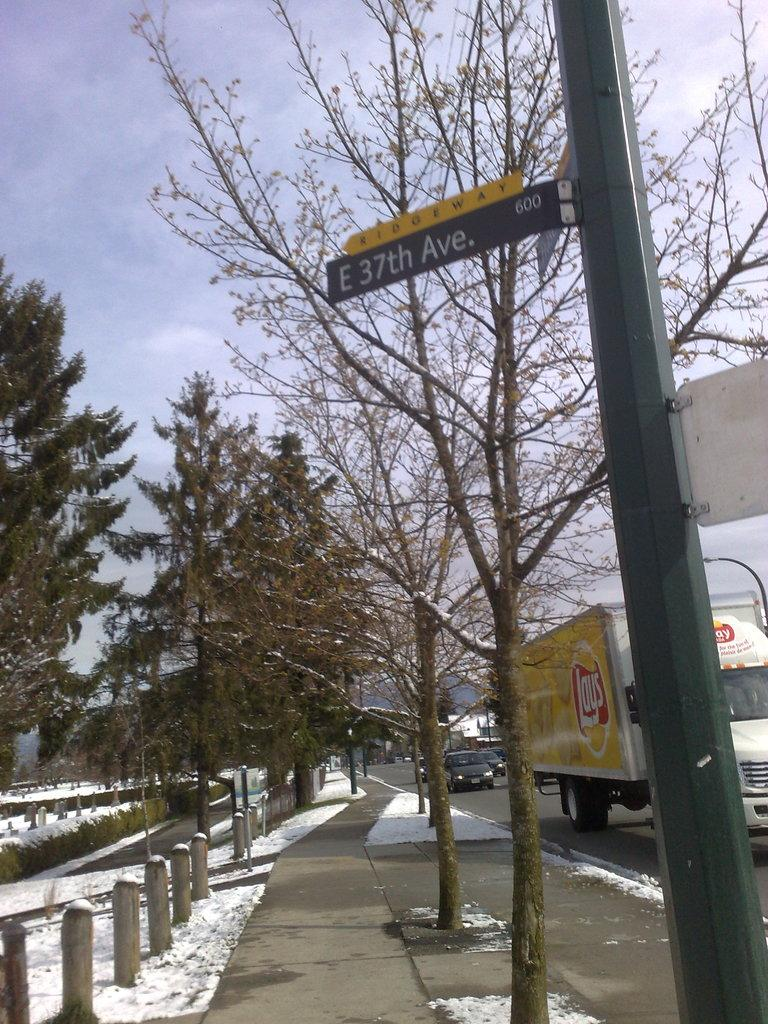What type of vegetation can be seen on the sidewalks in the image? There are trees on the sidewalks in the image. What is covering the ground in the image? There is snow on the ground in the image. What is attached to the pole in the image? There is a pole with a name board in the image. What is happening on the road in the image? Vehicles are moving on the road in the image. What is the condition of the sky in the image? The sky is cloudy in the image. What type of trousers is the snow wearing in the image? There is no snow wearing trousers in the image; snow is a natural substance and does not have the ability to wear clothing. What activity is the impulse participating in on the sidewalk in the image? There is no impulse present in the image, and therefore no such activity can be observed. 